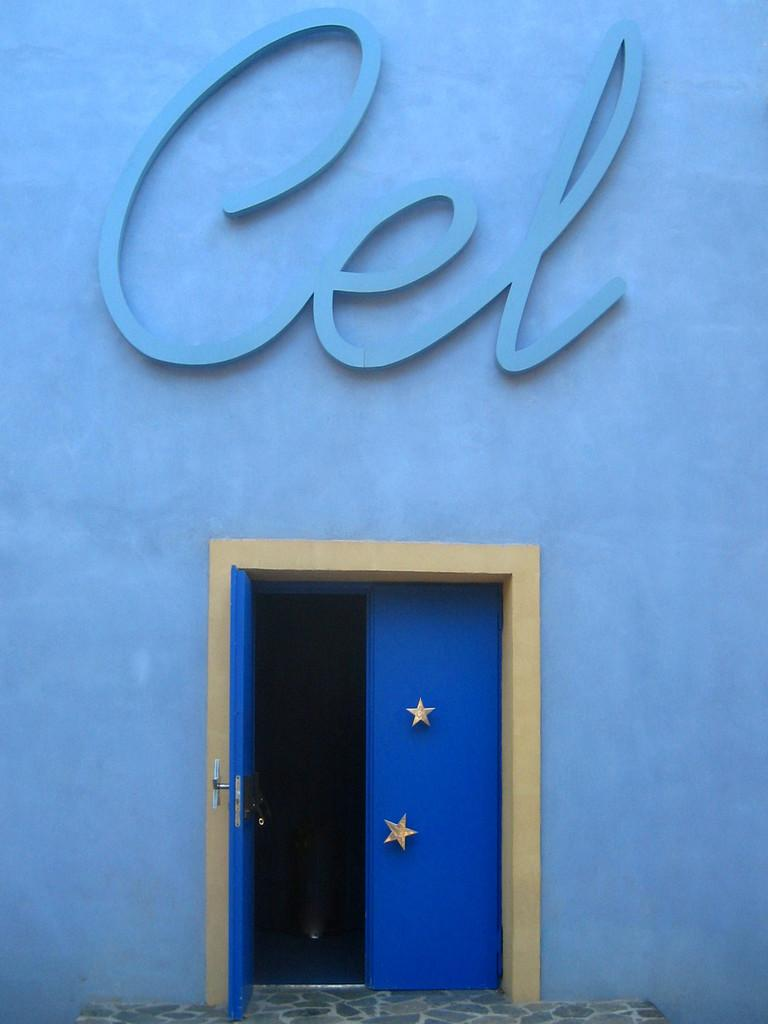What color is the wall in the image? The wall in the image is blue. What can be found on the wall in the image? There are doors in the image. What decorative elements are present on the doors? There are stars on the doors. What type of rhythm can be heard coming from the glass in the image? There is no glass present in the image, and therefore no rhythm can be heard. 